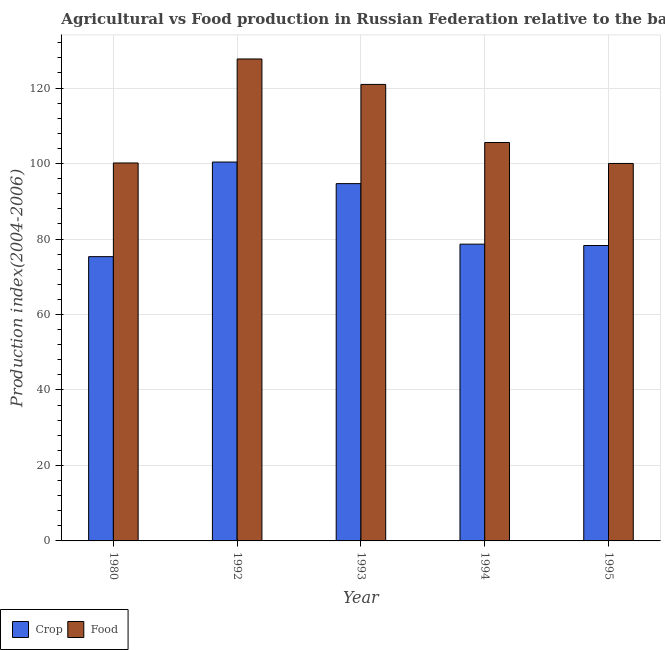How many different coloured bars are there?
Your response must be concise. 2. How many groups of bars are there?
Offer a very short reply. 5. How many bars are there on the 3rd tick from the left?
Provide a short and direct response. 2. How many bars are there on the 5th tick from the right?
Provide a succinct answer. 2. What is the label of the 5th group of bars from the left?
Offer a terse response. 1995. What is the food production index in 1992?
Provide a short and direct response. 127.71. Across all years, what is the maximum food production index?
Ensure brevity in your answer.  127.71. Across all years, what is the minimum crop production index?
Keep it short and to the point. 75.33. What is the total crop production index in the graph?
Give a very brief answer. 427.33. What is the difference between the crop production index in 1992 and that in 1994?
Give a very brief answer. 21.76. What is the difference between the food production index in 1994 and the crop production index in 1995?
Your response must be concise. 5.55. What is the average food production index per year?
Provide a short and direct response. 110.88. What is the ratio of the food production index in 1992 to that in 1995?
Your answer should be compact. 1.28. Is the food production index in 1980 less than that in 1995?
Your response must be concise. No. Is the difference between the food production index in 1992 and 1994 greater than the difference between the crop production index in 1992 and 1994?
Your answer should be very brief. No. What is the difference between the highest and the second highest food production index?
Ensure brevity in your answer.  6.74. What is the difference between the highest and the lowest crop production index?
Give a very brief answer. 25.07. In how many years, is the food production index greater than the average food production index taken over all years?
Your answer should be very brief. 2. Is the sum of the crop production index in 1992 and 1995 greater than the maximum food production index across all years?
Your response must be concise. Yes. What does the 1st bar from the left in 1995 represents?
Your answer should be compact. Crop. What does the 2nd bar from the right in 1992 represents?
Provide a short and direct response. Crop. How many bars are there?
Offer a terse response. 10. How many years are there in the graph?
Give a very brief answer. 5. What is the difference between two consecutive major ticks on the Y-axis?
Keep it short and to the point. 20. Does the graph contain any zero values?
Ensure brevity in your answer.  No. How many legend labels are there?
Offer a terse response. 2. How are the legend labels stacked?
Offer a terse response. Horizontal. What is the title of the graph?
Provide a succinct answer. Agricultural vs Food production in Russian Federation relative to the base period 2004-2006. What is the label or title of the X-axis?
Your answer should be very brief. Year. What is the label or title of the Y-axis?
Make the answer very short. Production index(2004-2006). What is the Production index(2004-2006) of Crop in 1980?
Offer a very short reply. 75.33. What is the Production index(2004-2006) of Food in 1980?
Keep it short and to the point. 100.15. What is the Production index(2004-2006) of Crop in 1992?
Your answer should be very brief. 100.4. What is the Production index(2004-2006) in Food in 1992?
Give a very brief answer. 127.71. What is the Production index(2004-2006) in Crop in 1993?
Your response must be concise. 94.68. What is the Production index(2004-2006) in Food in 1993?
Your answer should be very brief. 120.97. What is the Production index(2004-2006) in Crop in 1994?
Keep it short and to the point. 78.64. What is the Production index(2004-2006) of Food in 1994?
Your answer should be very brief. 105.57. What is the Production index(2004-2006) in Crop in 1995?
Provide a succinct answer. 78.28. What is the Production index(2004-2006) of Food in 1995?
Ensure brevity in your answer.  100.02. Across all years, what is the maximum Production index(2004-2006) of Crop?
Make the answer very short. 100.4. Across all years, what is the maximum Production index(2004-2006) of Food?
Offer a very short reply. 127.71. Across all years, what is the minimum Production index(2004-2006) in Crop?
Keep it short and to the point. 75.33. Across all years, what is the minimum Production index(2004-2006) in Food?
Provide a short and direct response. 100.02. What is the total Production index(2004-2006) of Crop in the graph?
Keep it short and to the point. 427.33. What is the total Production index(2004-2006) in Food in the graph?
Give a very brief answer. 554.42. What is the difference between the Production index(2004-2006) of Crop in 1980 and that in 1992?
Your answer should be compact. -25.07. What is the difference between the Production index(2004-2006) in Food in 1980 and that in 1992?
Provide a short and direct response. -27.56. What is the difference between the Production index(2004-2006) in Crop in 1980 and that in 1993?
Offer a terse response. -19.35. What is the difference between the Production index(2004-2006) in Food in 1980 and that in 1993?
Your answer should be compact. -20.82. What is the difference between the Production index(2004-2006) in Crop in 1980 and that in 1994?
Your response must be concise. -3.31. What is the difference between the Production index(2004-2006) of Food in 1980 and that in 1994?
Make the answer very short. -5.42. What is the difference between the Production index(2004-2006) in Crop in 1980 and that in 1995?
Your answer should be very brief. -2.95. What is the difference between the Production index(2004-2006) in Food in 1980 and that in 1995?
Keep it short and to the point. 0.13. What is the difference between the Production index(2004-2006) in Crop in 1992 and that in 1993?
Your response must be concise. 5.72. What is the difference between the Production index(2004-2006) in Food in 1992 and that in 1993?
Give a very brief answer. 6.74. What is the difference between the Production index(2004-2006) of Crop in 1992 and that in 1994?
Your answer should be compact. 21.76. What is the difference between the Production index(2004-2006) in Food in 1992 and that in 1994?
Give a very brief answer. 22.14. What is the difference between the Production index(2004-2006) of Crop in 1992 and that in 1995?
Your answer should be very brief. 22.12. What is the difference between the Production index(2004-2006) in Food in 1992 and that in 1995?
Provide a short and direct response. 27.69. What is the difference between the Production index(2004-2006) of Crop in 1993 and that in 1994?
Ensure brevity in your answer.  16.04. What is the difference between the Production index(2004-2006) of Food in 1993 and that in 1995?
Provide a succinct answer. 20.95. What is the difference between the Production index(2004-2006) of Crop in 1994 and that in 1995?
Keep it short and to the point. 0.36. What is the difference between the Production index(2004-2006) in Food in 1994 and that in 1995?
Your response must be concise. 5.55. What is the difference between the Production index(2004-2006) in Crop in 1980 and the Production index(2004-2006) in Food in 1992?
Provide a succinct answer. -52.38. What is the difference between the Production index(2004-2006) in Crop in 1980 and the Production index(2004-2006) in Food in 1993?
Offer a terse response. -45.64. What is the difference between the Production index(2004-2006) in Crop in 1980 and the Production index(2004-2006) in Food in 1994?
Keep it short and to the point. -30.24. What is the difference between the Production index(2004-2006) in Crop in 1980 and the Production index(2004-2006) in Food in 1995?
Your answer should be very brief. -24.69. What is the difference between the Production index(2004-2006) in Crop in 1992 and the Production index(2004-2006) in Food in 1993?
Keep it short and to the point. -20.57. What is the difference between the Production index(2004-2006) of Crop in 1992 and the Production index(2004-2006) of Food in 1994?
Your response must be concise. -5.17. What is the difference between the Production index(2004-2006) in Crop in 1992 and the Production index(2004-2006) in Food in 1995?
Offer a terse response. 0.38. What is the difference between the Production index(2004-2006) in Crop in 1993 and the Production index(2004-2006) in Food in 1994?
Keep it short and to the point. -10.89. What is the difference between the Production index(2004-2006) in Crop in 1993 and the Production index(2004-2006) in Food in 1995?
Give a very brief answer. -5.34. What is the difference between the Production index(2004-2006) in Crop in 1994 and the Production index(2004-2006) in Food in 1995?
Provide a short and direct response. -21.38. What is the average Production index(2004-2006) of Crop per year?
Your answer should be compact. 85.47. What is the average Production index(2004-2006) in Food per year?
Offer a very short reply. 110.88. In the year 1980, what is the difference between the Production index(2004-2006) in Crop and Production index(2004-2006) in Food?
Your response must be concise. -24.82. In the year 1992, what is the difference between the Production index(2004-2006) of Crop and Production index(2004-2006) of Food?
Offer a very short reply. -27.31. In the year 1993, what is the difference between the Production index(2004-2006) of Crop and Production index(2004-2006) of Food?
Your answer should be compact. -26.29. In the year 1994, what is the difference between the Production index(2004-2006) in Crop and Production index(2004-2006) in Food?
Your response must be concise. -26.93. In the year 1995, what is the difference between the Production index(2004-2006) in Crop and Production index(2004-2006) in Food?
Provide a short and direct response. -21.74. What is the ratio of the Production index(2004-2006) of Crop in 1980 to that in 1992?
Provide a short and direct response. 0.75. What is the ratio of the Production index(2004-2006) of Food in 1980 to that in 1992?
Keep it short and to the point. 0.78. What is the ratio of the Production index(2004-2006) of Crop in 1980 to that in 1993?
Provide a short and direct response. 0.8. What is the ratio of the Production index(2004-2006) in Food in 1980 to that in 1993?
Offer a terse response. 0.83. What is the ratio of the Production index(2004-2006) of Crop in 1980 to that in 1994?
Your answer should be very brief. 0.96. What is the ratio of the Production index(2004-2006) of Food in 1980 to that in 1994?
Your response must be concise. 0.95. What is the ratio of the Production index(2004-2006) of Crop in 1980 to that in 1995?
Provide a short and direct response. 0.96. What is the ratio of the Production index(2004-2006) in Food in 1980 to that in 1995?
Offer a very short reply. 1. What is the ratio of the Production index(2004-2006) of Crop in 1992 to that in 1993?
Offer a terse response. 1.06. What is the ratio of the Production index(2004-2006) in Food in 1992 to that in 1993?
Make the answer very short. 1.06. What is the ratio of the Production index(2004-2006) of Crop in 1992 to that in 1994?
Offer a terse response. 1.28. What is the ratio of the Production index(2004-2006) of Food in 1992 to that in 1994?
Your answer should be very brief. 1.21. What is the ratio of the Production index(2004-2006) of Crop in 1992 to that in 1995?
Ensure brevity in your answer.  1.28. What is the ratio of the Production index(2004-2006) of Food in 1992 to that in 1995?
Ensure brevity in your answer.  1.28. What is the ratio of the Production index(2004-2006) of Crop in 1993 to that in 1994?
Provide a succinct answer. 1.2. What is the ratio of the Production index(2004-2006) in Food in 1993 to that in 1994?
Your answer should be very brief. 1.15. What is the ratio of the Production index(2004-2006) in Crop in 1993 to that in 1995?
Provide a short and direct response. 1.21. What is the ratio of the Production index(2004-2006) of Food in 1993 to that in 1995?
Keep it short and to the point. 1.21. What is the ratio of the Production index(2004-2006) in Crop in 1994 to that in 1995?
Offer a very short reply. 1. What is the ratio of the Production index(2004-2006) of Food in 1994 to that in 1995?
Give a very brief answer. 1.06. What is the difference between the highest and the second highest Production index(2004-2006) of Crop?
Make the answer very short. 5.72. What is the difference between the highest and the second highest Production index(2004-2006) of Food?
Make the answer very short. 6.74. What is the difference between the highest and the lowest Production index(2004-2006) in Crop?
Your response must be concise. 25.07. What is the difference between the highest and the lowest Production index(2004-2006) of Food?
Give a very brief answer. 27.69. 